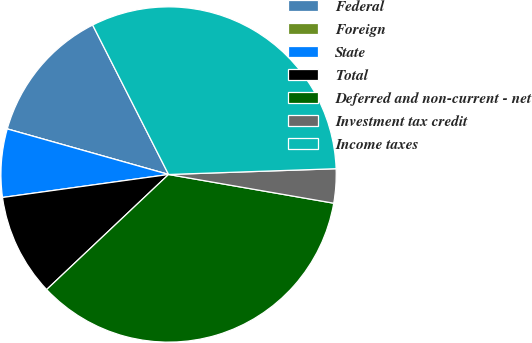Convert chart to OTSL. <chart><loc_0><loc_0><loc_500><loc_500><pie_chart><fcel>Federal<fcel>Foreign<fcel>State<fcel>Total<fcel>Deferred and non-current - net<fcel>Investment tax credit<fcel>Income taxes<nl><fcel>13.14%<fcel>0.0%<fcel>6.57%<fcel>9.85%<fcel>35.22%<fcel>3.29%<fcel>31.93%<nl></chart> 